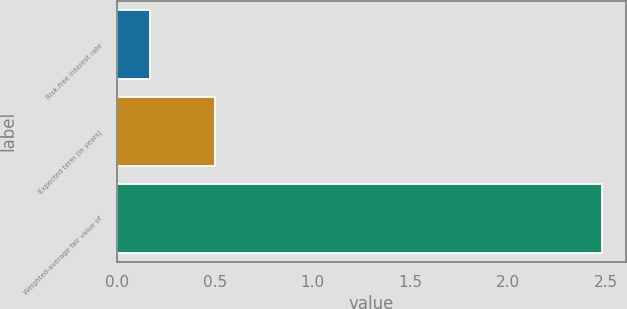<chart> <loc_0><loc_0><loc_500><loc_500><bar_chart><fcel>Risk-free interest rate<fcel>Expected term (in years)<fcel>Weighted-average fair value of<nl><fcel>0.17<fcel>0.5<fcel>2.48<nl></chart> 